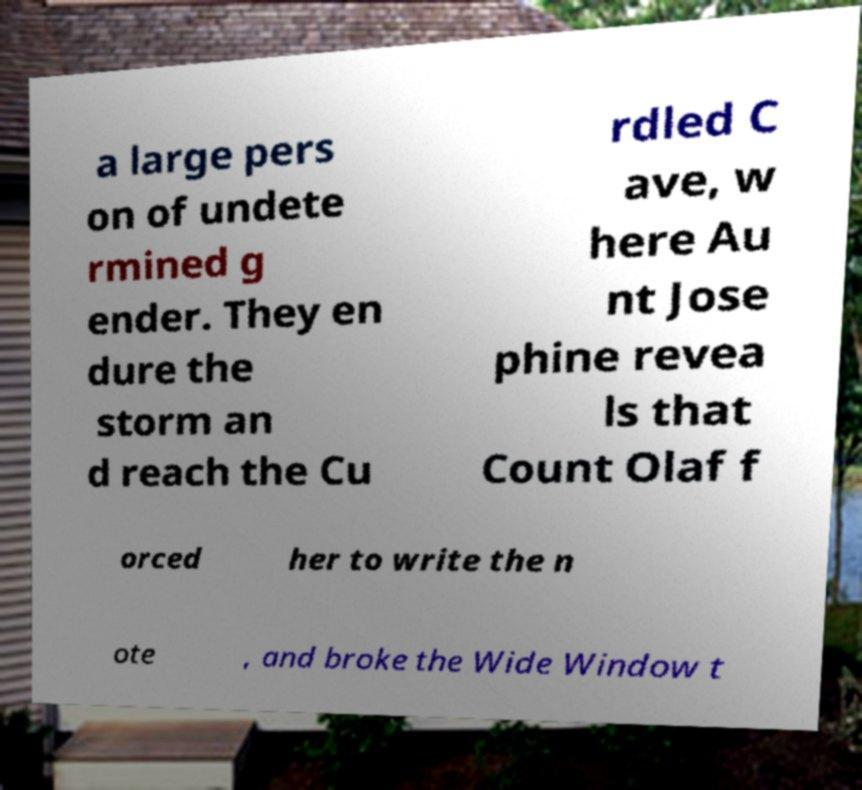Please identify and transcribe the text found in this image. a large pers on of undete rmined g ender. They en dure the storm an d reach the Cu rdled C ave, w here Au nt Jose phine revea ls that Count Olaf f orced her to write the n ote , and broke the Wide Window t 